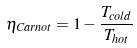<formula> <loc_0><loc_0><loc_500><loc_500>\eta _ { C a r n o t } = 1 - \frac { T _ { c o l d } } { T _ { h o t } }</formula> 